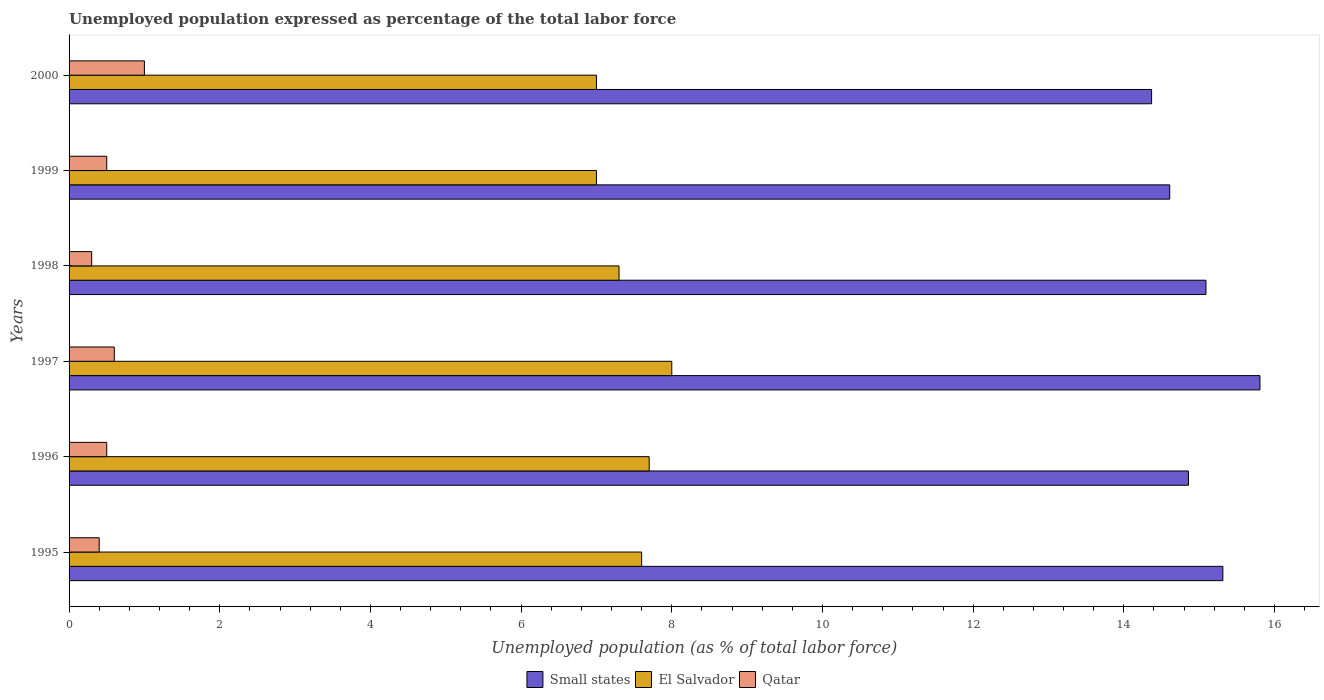How many different coloured bars are there?
Offer a very short reply. 3. How many groups of bars are there?
Keep it short and to the point. 6. Are the number of bars per tick equal to the number of legend labels?
Provide a succinct answer. Yes. Are the number of bars on each tick of the Y-axis equal?
Your response must be concise. Yes. How many bars are there on the 6th tick from the top?
Provide a short and direct response. 3. How many bars are there on the 3rd tick from the bottom?
Your answer should be very brief. 3. What is the unemployment in in Small states in 1998?
Your answer should be very brief. 15.09. Across all years, what is the minimum unemployment in in Qatar?
Make the answer very short. 0.3. In which year was the unemployment in in Small states maximum?
Offer a terse response. 1997. What is the total unemployment in in El Salvador in the graph?
Your answer should be very brief. 44.6. What is the difference between the unemployment in in El Salvador in 1995 and that in 1997?
Keep it short and to the point. -0.4. What is the difference between the unemployment in in Qatar in 1996 and the unemployment in in El Salvador in 1998?
Provide a succinct answer. -6.8. What is the average unemployment in in Qatar per year?
Ensure brevity in your answer.  0.55. In the year 1997, what is the difference between the unemployment in in Small states and unemployment in in El Salvador?
Provide a short and direct response. 7.81. What is the ratio of the unemployment in in Small states in 1998 to that in 2000?
Give a very brief answer. 1.05. Is the difference between the unemployment in in Small states in 1997 and 1998 greater than the difference between the unemployment in in El Salvador in 1997 and 1998?
Offer a very short reply. Yes. What is the difference between the highest and the second highest unemployment in in Qatar?
Provide a succinct answer. 0.4. In how many years, is the unemployment in in El Salvador greater than the average unemployment in in El Salvador taken over all years?
Offer a very short reply. 3. What does the 1st bar from the top in 1995 represents?
Ensure brevity in your answer.  Qatar. What does the 3rd bar from the bottom in 1996 represents?
Provide a succinct answer. Qatar. How many bars are there?
Ensure brevity in your answer.  18. Are all the bars in the graph horizontal?
Make the answer very short. Yes. What is the difference between two consecutive major ticks on the X-axis?
Your answer should be very brief. 2. Does the graph contain grids?
Provide a succinct answer. No. Where does the legend appear in the graph?
Offer a terse response. Bottom center. What is the title of the graph?
Your answer should be compact. Unemployed population expressed as percentage of the total labor force. What is the label or title of the X-axis?
Your response must be concise. Unemployed population (as % of total labor force). What is the Unemployed population (as % of total labor force) of Small states in 1995?
Keep it short and to the point. 15.31. What is the Unemployed population (as % of total labor force) of El Salvador in 1995?
Your response must be concise. 7.6. What is the Unemployed population (as % of total labor force) in Qatar in 1995?
Your answer should be very brief. 0.4. What is the Unemployed population (as % of total labor force) of Small states in 1996?
Give a very brief answer. 14.86. What is the Unemployed population (as % of total labor force) in El Salvador in 1996?
Give a very brief answer. 7.7. What is the Unemployed population (as % of total labor force) of Qatar in 1996?
Your answer should be compact. 0.5. What is the Unemployed population (as % of total labor force) of Small states in 1997?
Offer a very short reply. 15.81. What is the Unemployed population (as % of total labor force) of El Salvador in 1997?
Offer a very short reply. 8. What is the Unemployed population (as % of total labor force) of Qatar in 1997?
Offer a very short reply. 0.6. What is the Unemployed population (as % of total labor force) in Small states in 1998?
Keep it short and to the point. 15.09. What is the Unemployed population (as % of total labor force) of El Salvador in 1998?
Ensure brevity in your answer.  7.3. What is the Unemployed population (as % of total labor force) in Qatar in 1998?
Keep it short and to the point. 0.3. What is the Unemployed population (as % of total labor force) in Small states in 1999?
Provide a succinct answer. 14.61. What is the Unemployed population (as % of total labor force) in Qatar in 1999?
Make the answer very short. 0.5. What is the Unemployed population (as % of total labor force) of Small states in 2000?
Provide a short and direct response. 14.37. What is the Unemployed population (as % of total labor force) in El Salvador in 2000?
Offer a terse response. 7. What is the Unemployed population (as % of total labor force) of Qatar in 2000?
Offer a very short reply. 1. Across all years, what is the maximum Unemployed population (as % of total labor force) of Small states?
Offer a very short reply. 15.81. Across all years, what is the minimum Unemployed population (as % of total labor force) in Small states?
Make the answer very short. 14.37. Across all years, what is the minimum Unemployed population (as % of total labor force) of El Salvador?
Your answer should be very brief. 7. Across all years, what is the minimum Unemployed population (as % of total labor force) of Qatar?
Make the answer very short. 0.3. What is the total Unemployed population (as % of total labor force) of Small states in the graph?
Keep it short and to the point. 90.05. What is the total Unemployed population (as % of total labor force) of El Salvador in the graph?
Your response must be concise. 44.6. What is the total Unemployed population (as % of total labor force) of Qatar in the graph?
Keep it short and to the point. 3.3. What is the difference between the Unemployed population (as % of total labor force) of Small states in 1995 and that in 1996?
Offer a terse response. 0.46. What is the difference between the Unemployed population (as % of total labor force) of Small states in 1995 and that in 1997?
Give a very brief answer. -0.49. What is the difference between the Unemployed population (as % of total labor force) of Small states in 1995 and that in 1998?
Your response must be concise. 0.22. What is the difference between the Unemployed population (as % of total labor force) in El Salvador in 1995 and that in 1998?
Make the answer very short. 0.3. What is the difference between the Unemployed population (as % of total labor force) in Small states in 1995 and that in 1999?
Ensure brevity in your answer.  0.71. What is the difference between the Unemployed population (as % of total labor force) in El Salvador in 1995 and that in 1999?
Provide a short and direct response. 0.6. What is the difference between the Unemployed population (as % of total labor force) of Qatar in 1995 and that in 1999?
Provide a short and direct response. -0.1. What is the difference between the Unemployed population (as % of total labor force) of Small states in 1995 and that in 2000?
Keep it short and to the point. 0.95. What is the difference between the Unemployed population (as % of total labor force) of Small states in 1996 and that in 1997?
Your answer should be compact. -0.95. What is the difference between the Unemployed population (as % of total labor force) of El Salvador in 1996 and that in 1997?
Offer a terse response. -0.3. What is the difference between the Unemployed population (as % of total labor force) in Small states in 1996 and that in 1998?
Make the answer very short. -0.23. What is the difference between the Unemployed population (as % of total labor force) in El Salvador in 1996 and that in 1998?
Provide a short and direct response. 0.4. What is the difference between the Unemployed population (as % of total labor force) in Qatar in 1996 and that in 1998?
Ensure brevity in your answer.  0.2. What is the difference between the Unemployed population (as % of total labor force) in Small states in 1996 and that in 1999?
Keep it short and to the point. 0.25. What is the difference between the Unemployed population (as % of total labor force) in Qatar in 1996 and that in 1999?
Your answer should be compact. 0. What is the difference between the Unemployed population (as % of total labor force) in Small states in 1996 and that in 2000?
Your answer should be very brief. 0.49. What is the difference between the Unemployed population (as % of total labor force) of Qatar in 1996 and that in 2000?
Provide a short and direct response. -0.5. What is the difference between the Unemployed population (as % of total labor force) in Small states in 1997 and that in 1998?
Your answer should be very brief. 0.72. What is the difference between the Unemployed population (as % of total labor force) in El Salvador in 1997 and that in 1998?
Keep it short and to the point. 0.7. What is the difference between the Unemployed population (as % of total labor force) of Small states in 1997 and that in 1999?
Offer a very short reply. 1.2. What is the difference between the Unemployed population (as % of total labor force) of Qatar in 1997 and that in 1999?
Your answer should be very brief. 0.1. What is the difference between the Unemployed population (as % of total labor force) of Small states in 1997 and that in 2000?
Offer a terse response. 1.44. What is the difference between the Unemployed population (as % of total labor force) of El Salvador in 1997 and that in 2000?
Offer a very short reply. 1. What is the difference between the Unemployed population (as % of total labor force) in Small states in 1998 and that in 1999?
Offer a very short reply. 0.48. What is the difference between the Unemployed population (as % of total labor force) in Small states in 1998 and that in 2000?
Give a very brief answer. 0.72. What is the difference between the Unemployed population (as % of total labor force) of El Salvador in 1998 and that in 2000?
Provide a short and direct response. 0.3. What is the difference between the Unemployed population (as % of total labor force) in Small states in 1999 and that in 2000?
Provide a succinct answer. 0.24. What is the difference between the Unemployed population (as % of total labor force) of El Salvador in 1999 and that in 2000?
Keep it short and to the point. 0. What is the difference between the Unemployed population (as % of total labor force) of Small states in 1995 and the Unemployed population (as % of total labor force) of El Salvador in 1996?
Offer a very short reply. 7.61. What is the difference between the Unemployed population (as % of total labor force) of Small states in 1995 and the Unemployed population (as % of total labor force) of Qatar in 1996?
Give a very brief answer. 14.81. What is the difference between the Unemployed population (as % of total labor force) in El Salvador in 1995 and the Unemployed population (as % of total labor force) in Qatar in 1996?
Offer a terse response. 7.1. What is the difference between the Unemployed population (as % of total labor force) in Small states in 1995 and the Unemployed population (as % of total labor force) in El Salvador in 1997?
Keep it short and to the point. 7.31. What is the difference between the Unemployed population (as % of total labor force) in Small states in 1995 and the Unemployed population (as % of total labor force) in Qatar in 1997?
Your answer should be very brief. 14.71. What is the difference between the Unemployed population (as % of total labor force) in Small states in 1995 and the Unemployed population (as % of total labor force) in El Salvador in 1998?
Provide a succinct answer. 8.01. What is the difference between the Unemployed population (as % of total labor force) in Small states in 1995 and the Unemployed population (as % of total labor force) in Qatar in 1998?
Make the answer very short. 15.01. What is the difference between the Unemployed population (as % of total labor force) in El Salvador in 1995 and the Unemployed population (as % of total labor force) in Qatar in 1998?
Offer a terse response. 7.3. What is the difference between the Unemployed population (as % of total labor force) in Small states in 1995 and the Unemployed population (as % of total labor force) in El Salvador in 1999?
Your answer should be compact. 8.31. What is the difference between the Unemployed population (as % of total labor force) of Small states in 1995 and the Unemployed population (as % of total labor force) of Qatar in 1999?
Your response must be concise. 14.81. What is the difference between the Unemployed population (as % of total labor force) of Small states in 1995 and the Unemployed population (as % of total labor force) of El Salvador in 2000?
Provide a short and direct response. 8.31. What is the difference between the Unemployed population (as % of total labor force) of Small states in 1995 and the Unemployed population (as % of total labor force) of Qatar in 2000?
Keep it short and to the point. 14.31. What is the difference between the Unemployed population (as % of total labor force) in El Salvador in 1995 and the Unemployed population (as % of total labor force) in Qatar in 2000?
Offer a terse response. 6.6. What is the difference between the Unemployed population (as % of total labor force) of Small states in 1996 and the Unemployed population (as % of total labor force) of El Salvador in 1997?
Make the answer very short. 6.86. What is the difference between the Unemployed population (as % of total labor force) in Small states in 1996 and the Unemployed population (as % of total labor force) in Qatar in 1997?
Provide a succinct answer. 14.26. What is the difference between the Unemployed population (as % of total labor force) of El Salvador in 1996 and the Unemployed population (as % of total labor force) of Qatar in 1997?
Your answer should be compact. 7.1. What is the difference between the Unemployed population (as % of total labor force) in Small states in 1996 and the Unemployed population (as % of total labor force) in El Salvador in 1998?
Provide a succinct answer. 7.56. What is the difference between the Unemployed population (as % of total labor force) of Small states in 1996 and the Unemployed population (as % of total labor force) of Qatar in 1998?
Offer a terse response. 14.56. What is the difference between the Unemployed population (as % of total labor force) of El Salvador in 1996 and the Unemployed population (as % of total labor force) of Qatar in 1998?
Your response must be concise. 7.4. What is the difference between the Unemployed population (as % of total labor force) in Small states in 1996 and the Unemployed population (as % of total labor force) in El Salvador in 1999?
Your response must be concise. 7.86. What is the difference between the Unemployed population (as % of total labor force) of Small states in 1996 and the Unemployed population (as % of total labor force) of Qatar in 1999?
Offer a very short reply. 14.36. What is the difference between the Unemployed population (as % of total labor force) in El Salvador in 1996 and the Unemployed population (as % of total labor force) in Qatar in 1999?
Ensure brevity in your answer.  7.2. What is the difference between the Unemployed population (as % of total labor force) in Small states in 1996 and the Unemployed population (as % of total labor force) in El Salvador in 2000?
Your answer should be compact. 7.86. What is the difference between the Unemployed population (as % of total labor force) of Small states in 1996 and the Unemployed population (as % of total labor force) of Qatar in 2000?
Your answer should be compact. 13.86. What is the difference between the Unemployed population (as % of total labor force) of Small states in 1997 and the Unemployed population (as % of total labor force) of El Salvador in 1998?
Your answer should be compact. 8.51. What is the difference between the Unemployed population (as % of total labor force) of Small states in 1997 and the Unemployed population (as % of total labor force) of Qatar in 1998?
Ensure brevity in your answer.  15.51. What is the difference between the Unemployed population (as % of total labor force) of El Salvador in 1997 and the Unemployed population (as % of total labor force) of Qatar in 1998?
Your answer should be very brief. 7.7. What is the difference between the Unemployed population (as % of total labor force) of Small states in 1997 and the Unemployed population (as % of total labor force) of El Salvador in 1999?
Offer a very short reply. 8.81. What is the difference between the Unemployed population (as % of total labor force) in Small states in 1997 and the Unemployed population (as % of total labor force) in Qatar in 1999?
Give a very brief answer. 15.31. What is the difference between the Unemployed population (as % of total labor force) in El Salvador in 1997 and the Unemployed population (as % of total labor force) in Qatar in 1999?
Your answer should be compact. 7.5. What is the difference between the Unemployed population (as % of total labor force) in Small states in 1997 and the Unemployed population (as % of total labor force) in El Salvador in 2000?
Offer a terse response. 8.81. What is the difference between the Unemployed population (as % of total labor force) of Small states in 1997 and the Unemployed population (as % of total labor force) of Qatar in 2000?
Provide a succinct answer. 14.81. What is the difference between the Unemployed population (as % of total labor force) in Small states in 1998 and the Unemployed population (as % of total labor force) in El Salvador in 1999?
Provide a succinct answer. 8.09. What is the difference between the Unemployed population (as % of total labor force) of Small states in 1998 and the Unemployed population (as % of total labor force) of Qatar in 1999?
Keep it short and to the point. 14.59. What is the difference between the Unemployed population (as % of total labor force) of El Salvador in 1998 and the Unemployed population (as % of total labor force) of Qatar in 1999?
Offer a very short reply. 6.8. What is the difference between the Unemployed population (as % of total labor force) of Small states in 1998 and the Unemployed population (as % of total labor force) of El Salvador in 2000?
Keep it short and to the point. 8.09. What is the difference between the Unemployed population (as % of total labor force) in Small states in 1998 and the Unemployed population (as % of total labor force) in Qatar in 2000?
Provide a succinct answer. 14.09. What is the difference between the Unemployed population (as % of total labor force) in Small states in 1999 and the Unemployed population (as % of total labor force) in El Salvador in 2000?
Your answer should be very brief. 7.61. What is the difference between the Unemployed population (as % of total labor force) in Small states in 1999 and the Unemployed population (as % of total labor force) in Qatar in 2000?
Your answer should be very brief. 13.61. What is the average Unemployed population (as % of total labor force) of Small states per year?
Offer a terse response. 15.01. What is the average Unemployed population (as % of total labor force) of El Salvador per year?
Ensure brevity in your answer.  7.43. What is the average Unemployed population (as % of total labor force) of Qatar per year?
Your response must be concise. 0.55. In the year 1995, what is the difference between the Unemployed population (as % of total labor force) in Small states and Unemployed population (as % of total labor force) in El Salvador?
Provide a short and direct response. 7.71. In the year 1995, what is the difference between the Unemployed population (as % of total labor force) in Small states and Unemployed population (as % of total labor force) in Qatar?
Provide a short and direct response. 14.91. In the year 1995, what is the difference between the Unemployed population (as % of total labor force) of El Salvador and Unemployed population (as % of total labor force) of Qatar?
Ensure brevity in your answer.  7.2. In the year 1996, what is the difference between the Unemployed population (as % of total labor force) in Small states and Unemployed population (as % of total labor force) in El Salvador?
Make the answer very short. 7.16. In the year 1996, what is the difference between the Unemployed population (as % of total labor force) in Small states and Unemployed population (as % of total labor force) in Qatar?
Ensure brevity in your answer.  14.36. In the year 1996, what is the difference between the Unemployed population (as % of total labor force) of El Salvador and Unemployed population (as % of total labor force) of Qatar?
Provide a succinct answer. 7.2. In the year 1997, what is the difference between the Unemployed population (as % of total labor force) of Small states and Unemployed population (as % of total labor force) of El Salvador?
Your response must be concise. 7.81. In the year 1997, what is the difference between the Unemployed population (as % of total labor force) in Small states and Unemployed population (as % of total labor force) in Qatar?
Your answer should be compact. 15.21. In the year 1997, what is the difference between the Unemployed population (as % of total labor force) of El Salvador and Unemployed population (as % of total labor force) of Qatar?
Ensure brevity in your answer.  7.4. In the year 1998, what is the difference between the Unemployed population (as % of total labor force) in Small states and Unemployed population (as % of total labor force) in El Salvador?
Your answer should be compact. 7.79. In the year 1998, what is the difference between the Unemployed population (as % of total labor force) in Small states and Unemployed population (as % of total labor force) in Qatar?
Offer a terse response. 14.79. In the year 1998, what is the difference between the Unemployed population (as % of total labor force) in El Salvador and Unemployed population (as % of total labor force) in Qatar?
Give a very brief answer. 7. In the year 1999, what is the difference between the Unemployed population (as % of total labor force) of Small states and Unemployed population (as % of total labor force) of El Salvador?
Your answer should be very brief. 7.61. In the year 1999, what is the difference between the Unemployed population (as % of total labor force) of Small states and Unemployed population (as % of total labor force) of Qatar?
Keep it short and to the point. 14.11. In the year 2000, what is the difference between the Unemployed population (as % of total labor force) of Small states and Unemployed population (as % of total labor force) of El Salvador?
Your response must be concise. 7.37. In the year 2000, what is the difference between the Unemployed population (as % of total labor force) in Small states and Unemployed population (as % of total labor force) in Qatar?
Your answer should be compact. 13.37. In the year 2000, what is the difference between the Unemployed population (as % of total labor force) of El Salvador and Unemployed population (as % of total labor force) of Qatar?
Offer a terse response. 6. What is the ratio of the Unemployed population (as % of total labor force) in Small states in 1995 to that in 1996?
Give a very brief answer. 1.03. What is the ratio of the Unemployed population (as % of total labor force) of El Salvador in 1995 to that in 1996?
Provide a succinct answer. 0.99. What is the ratio of the Unemployed population (as % of total labor force) of Small states in 1995 to that in 1997?
Provide a short and direct response. 0.97. What is the ratio of the Unemployed population (as % of total labor force) of El Salvador in 1995 to that in 1997?
Offer a terse response. 0.95. What is the ratio of the Unemployed population (as % of total labor force) in Small states in 1995 to that in 1998?
Provide a succinct answer. 1.01. What is the ratio of the Unemployed population (as % of total labor force) in El Salvador in 1995 to that in 1998?
Your response must be concise. 1.04. What is the ratio of the Unemployed population (as % of total labor force) of Qatar in 1995 to that in 1998?
Give a very brief answer. 1.33. What is the ratio of the Unemployed population (as % of total labor force) in Small states in 1995 to that in 1999?
Make the answer very short. 1.05. What is the ratio of the Unemployed population (as % of total labor force) in El Salvador in 1995 to that in 1999?
Your answer should be very brief. 1.09. What is the ratio of the Unemployed population (as % of total labor force) of Small states in 1995 to that in 2000?
Your response must be concise. 1.07. What is the ratio of the Unemployed population (as % of total labor force) of El Salvador in 1995 to that in 2000?
Keep it short and to the point. 1.09. What is the ratio of the Unemployed population (as % of total labor force) of El Salvador in 1996 to that in 1997?
Keep it short and to the point. 0.96. What is the ratio of the Unemployed population (as % of total labor force) in Qatar in 1996 to that in 1997?
Give a very brief answer. 0.83. What is the ratio of the Unemployed population (as % of total labor force) in Small states in 1996 to that in 1998?
Offer a very short reply. 0.98. What is the ratio of the Unemployed population (as % of total labor force) of El Salvador in 1996 to that in 1998?
Provide a short and direct response. 1.05. What is the ratio of the Unemployed population (as % of total labor force) in El Salvador in 1996 to that in 1999?
Offer a terse response. 1.1. What is the ratio of the Unemployed population (as % of total labor force) of Small states in 1996 to that in 2000?
Your answer should be compact. 1.03. What is the ratio of the Unemployed population (as % of total labor force) in El Salvador in 1996 to that in 2000?
Your answer should be very brief. 1.1. What is the ratio of the Unemployed population (as % of total labor force) of Small states in 1997 to that in 1998?
Ensure brevity in your answer.  1.05. What is the ratio of the Unemployed population (as % of total labor force) of El Salvador in 1997 to that in 1998?
Your answer should be compact. 1.1. What is the ratio of the Unemployed population (as % of total labor force) in Small states in 1997 to that in 1999?
Ensure brevity in your answer.  1.08. What is the ratio of the Unemployed population (as % of total labor force) of Small states in 1997 to that in 2000?
Give a very brief answer. 1.1. What is the ratio of the Unemployed population (as % of total labor force) in El Salvador in 1997 to that in 2000?
Provide a short and direct response. 1.14. What is the ratio of the Unemployed population (as % of total labor force) of Small states in 1998 to that in 1999?
Ensure brevity in your answer.  1.03. What is the ratio of the Unemployed population (as % of total labor force) in El Salvador in 1998 to that in 1999?
Your answer should be very brief. 1.04. What is the ratio of the Unemployed population (as % of total labor force) of Small states in 1998 to that in 2000?
Offer a terse response. 1.05. What is the ratio of the Unemployed population (as % of total labor force) of El Salvador in 1998 to that in 2000?
Offer a very short reply. 1.04. What is the ratio of the Unemployed population (as % of total labor force) of Small states in 1999 to that in 2000?
Keep it short and to the point. 1.02. What is the difference between the highest and the second highest Unemployed population (as % of total labor force) in Small states?
Provide a succinct answer. 0.49. What is the difference between the highest and the second highest Unemployed population (as % of total labor force) in Qatar?
Provide a succinct answer. 0.4. What is the difference between the highest and the lowest Unemployed population (as % of total labor force) of Small states?
Ensure brevity in your answer.  1.44. 